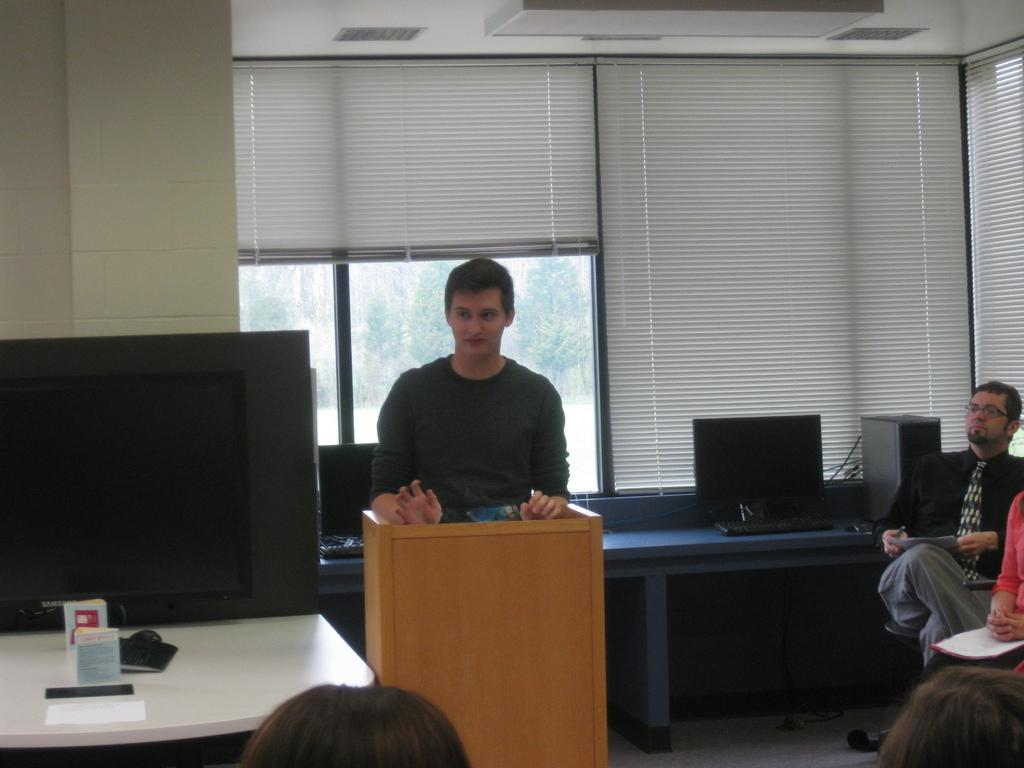How many people are present in the image? There are people in the image, but the exact number cannot be determined from the provided facts. What can be seen on the tables in the image? There are tables with devices on them in the image. What is visible through the window in the image? The ground and the roof are visible in the image, but it is not clear if they are visible through the window. What type of lighting is present in the image? There are lights in the image, but their specific type or function cannot be determined. What type of servant can be seen attending to the people in the image? There is no servant present in the image; it only shows people and tables with devices. What type of church can be seen in the background of the image? There is no church present in the image; it only shows people, tables, devices, a window, the ground, the roof, and lights. 